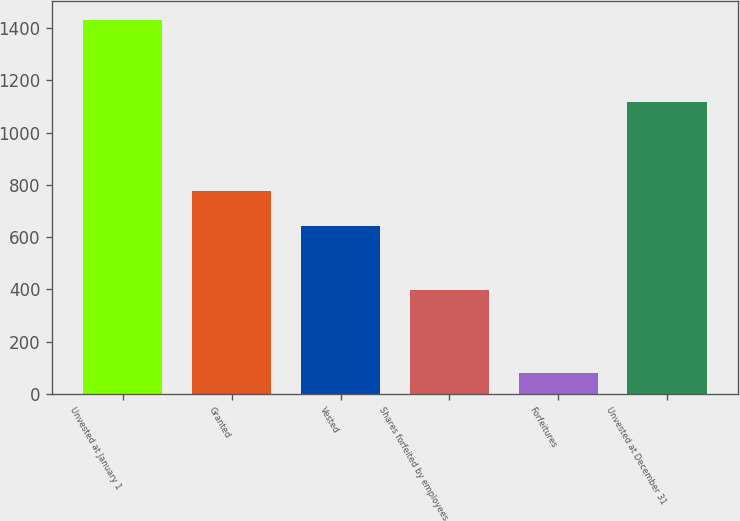Convert chart to OTSL. <chart><loc_0><loc_0><loc_500><loc_500><bar_chart><fcel>Unvested at January 1<fcel>Granted<fcel>Vested<fcel>Shares forfeited by employees<fcel>Forfeitures<fcel>Unvested at December 31<nl><fcel>1431<fcel>776.2<fcel>641<fcel>396<fcel>79<fcel>1117<nl></chart> 